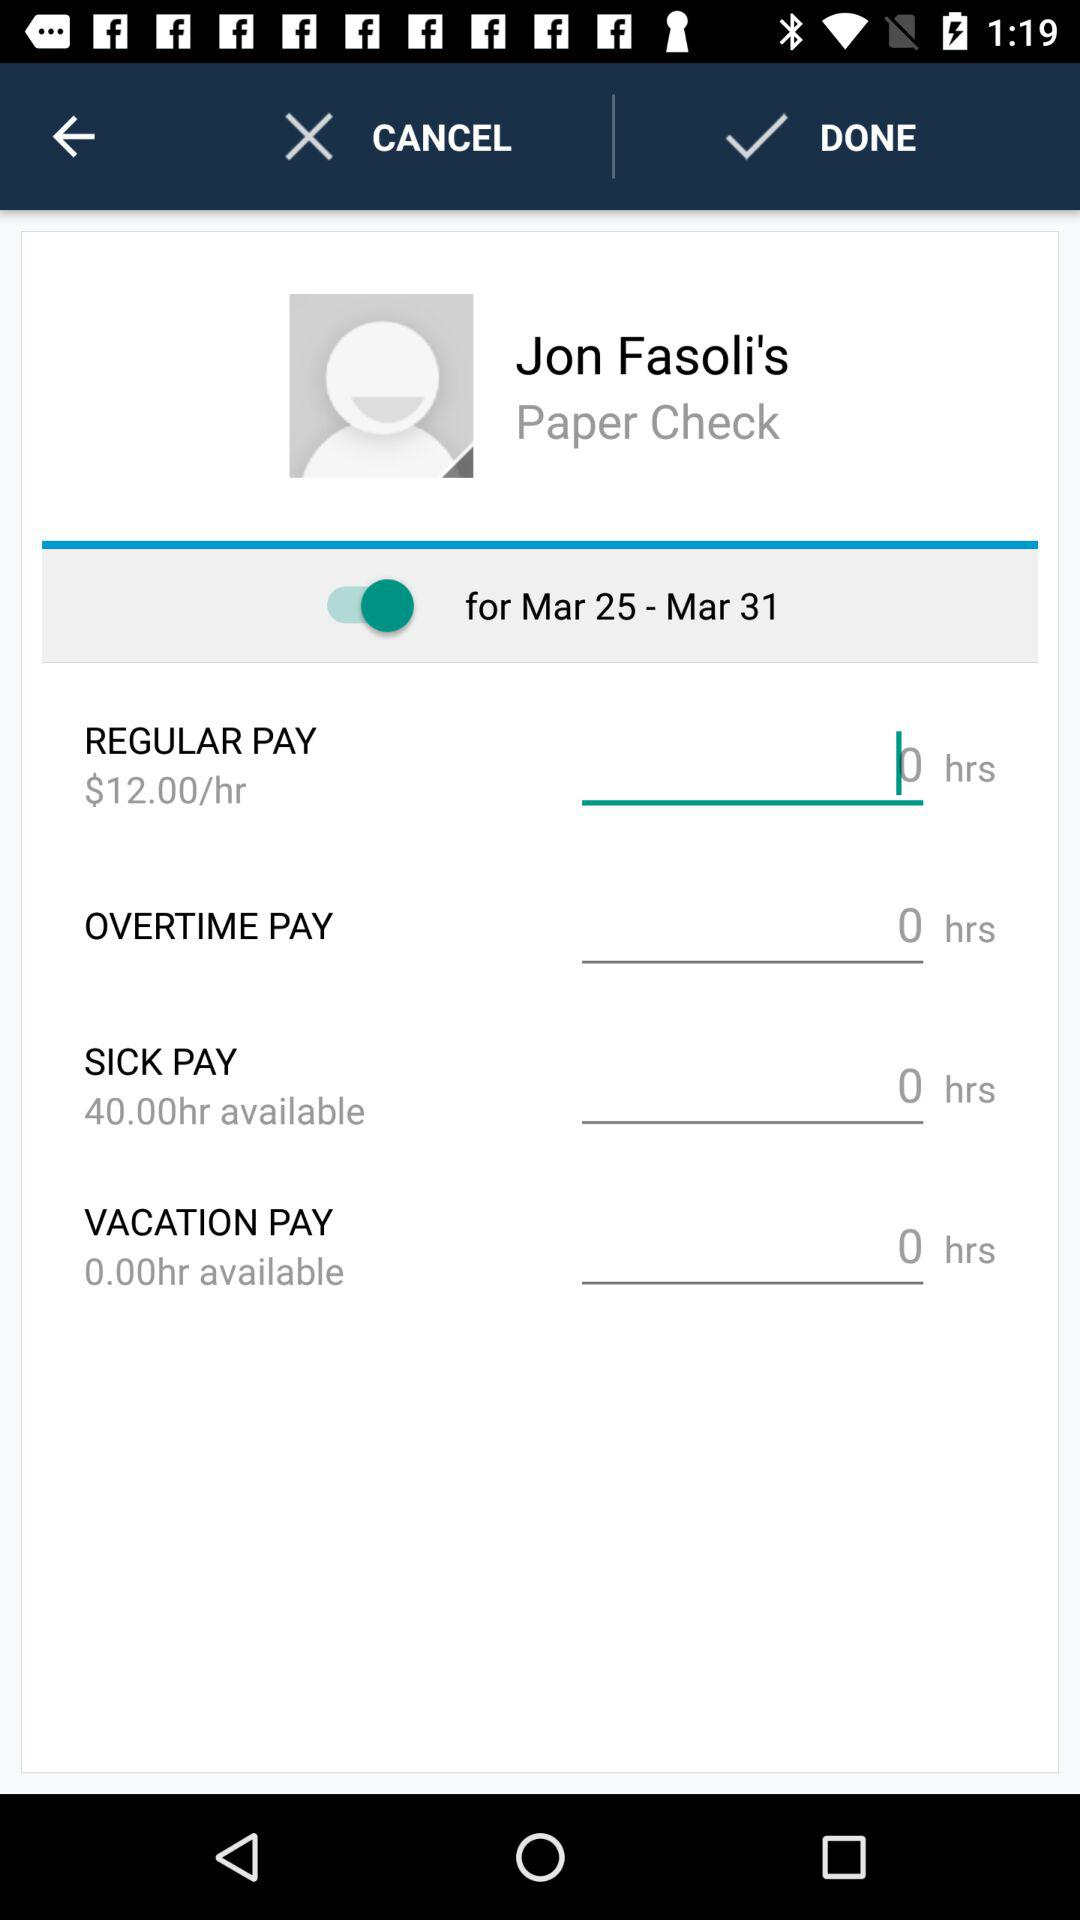What is the username? The username is "Jon Fasoli's". 